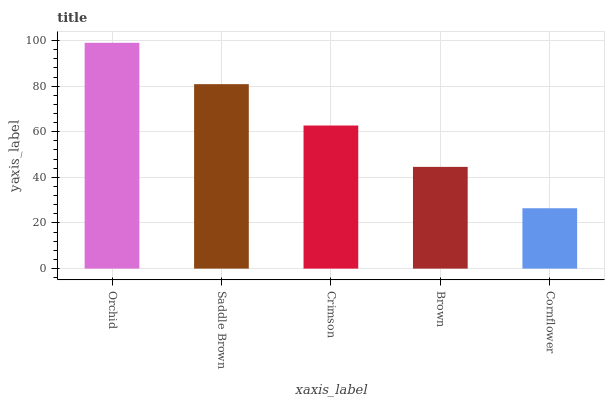Is Cornflower the minimum?
Answer yes or no. Yes. Is Orchid the maximum?
Answer yes or no. Yes. Is Saddle Brown the minimum?
Answer yes or no. No. Is Saddle Brown the maximum?
Answer yes or no. No. Is Orchid greater than Saddle Brown?
Answer yes or no. Yes. Is Saddle Brown less than Orchid?
Answer yes or no. Yes. Is Saddle Brown greater than Orchid?
Answer yes or no. No. Is Orchid less than Saddle Brown?
Answer yes or no. No. Is Crimson the high median?
Answer yes or no. Yes. Is Crimson the low median?
Answer yes or no. Yes. Is Cornflower the high median?
Answer yes or no. No. Is Brown the low median?
Answer yes or no. No. 